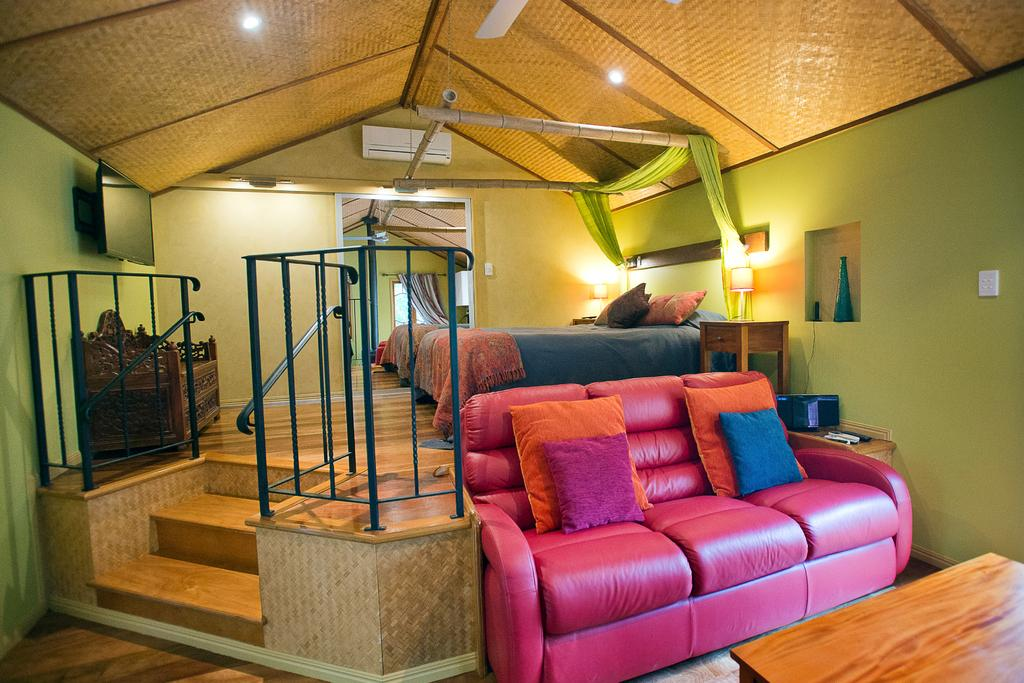Where is the setting of the image? The image is inside a house. What type of furniture can be seen in the image? There are sofas with pillows in the image. What other piece of furniture is present in the image? There is a bed in the image. What type of window treatment is present in the image? Curtains are present in the image. What type of lighting is visible in the image? Lights are visible in the image. What part of the room is visible in the image? The ceiling is visible in the image. What architectural feature is present in the image? Railings are present in the image. What type of flooring is visible in the image? The floor has a wooden finish. What type of entertainment device is present in the image? There is a television in the image. Can you see any goldfish swimming in the image? There are no goldfish present in the image. What type of seat is located near the television in the image? There is no specific seat mentioned in the image; only sofas and a bed are described. 